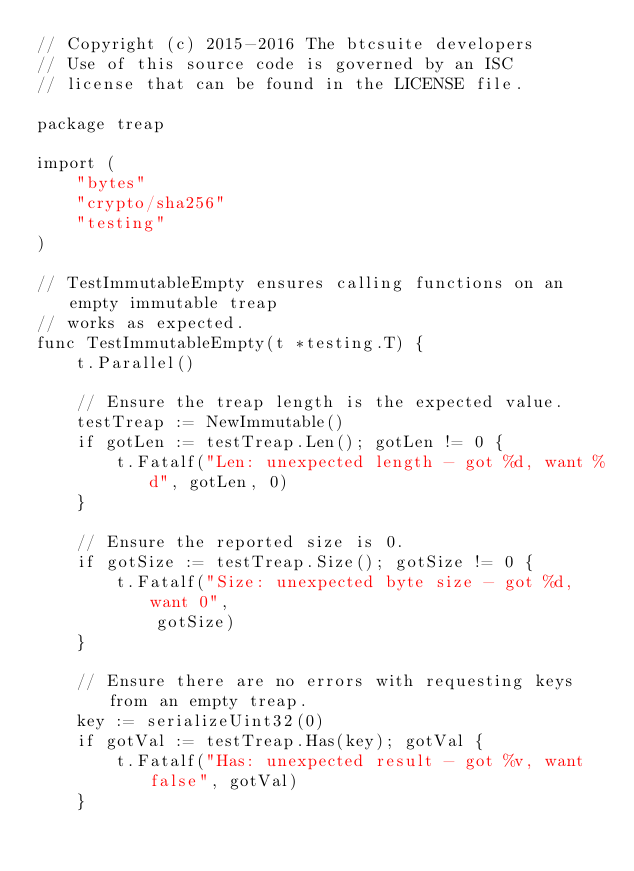Convert code to text. <code><loc_0><loc_0><loc_500><loc_500><_Go_>// Copyright (c) 2015-2016 The btcsuite developers
// Use of this source code is governed by an ISC
// license that can be found in the LICENSE file.

package treap

import (
	"bytes"
	"crypto/sha256"
	"testing"
)

// TestImmutableEmpty ensures calling functions on an empty immutable treap
// works as expected.
func TestImmutableEmpty(t *testing.T) {
	t.Parallel()

	// Ensure the treap length is the expected value.
	testTreap := NewImmutable()
	if gotLen := testTreap.Len(); gotLen != 0 {
		t.Fatalf("Len: unexpected length - got %d, want %d", gotLen, 0)
	}

	// Ensure the reported size is 0.
	if gotSize := testTreap.Size(); gotSize != 0 {
		t.Fatalf("Size: unexpected byte size - got %d, want 0",
			gotSize)
	}

	// Ensure there are no errors with requesting keys from an empty treap.
	key := serializeUint32(0)
	if gotVal := testTreap.Has(key); gotVal {
		t.Fatalf("Has: unexpected result - got %v, want false", gotVal)
	}</code> 